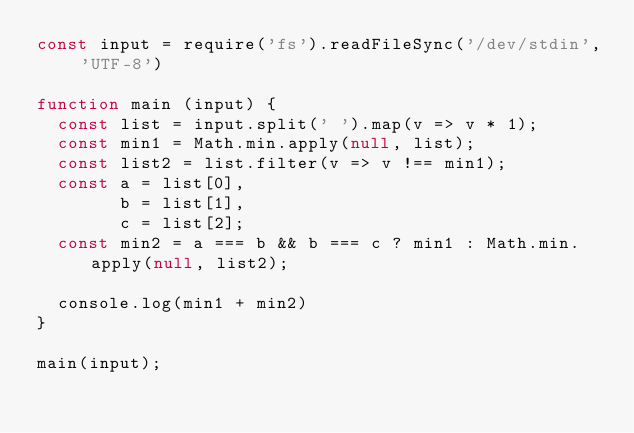Convert code to text. <code><loc_0><loc_0><loc_500><loc_500><_JavaScript_>const input = require('fs').readFileSync('/dev/stdin', 'UTF-8')

function main (input) {
  const list = input.split(' ').map(v => v * 1);
  const min1 = Math.min.apply(null, list);
  const list2 = list.filter(v => v !== min1);
  const a = list[0],
        b = list[1],
  	   	c = list[2];
  const min2 = a === b && b === c ? min1 : Math.min.apply(null, list2);
  
  console.log(min1 + min2)
}

main(input);</code> 